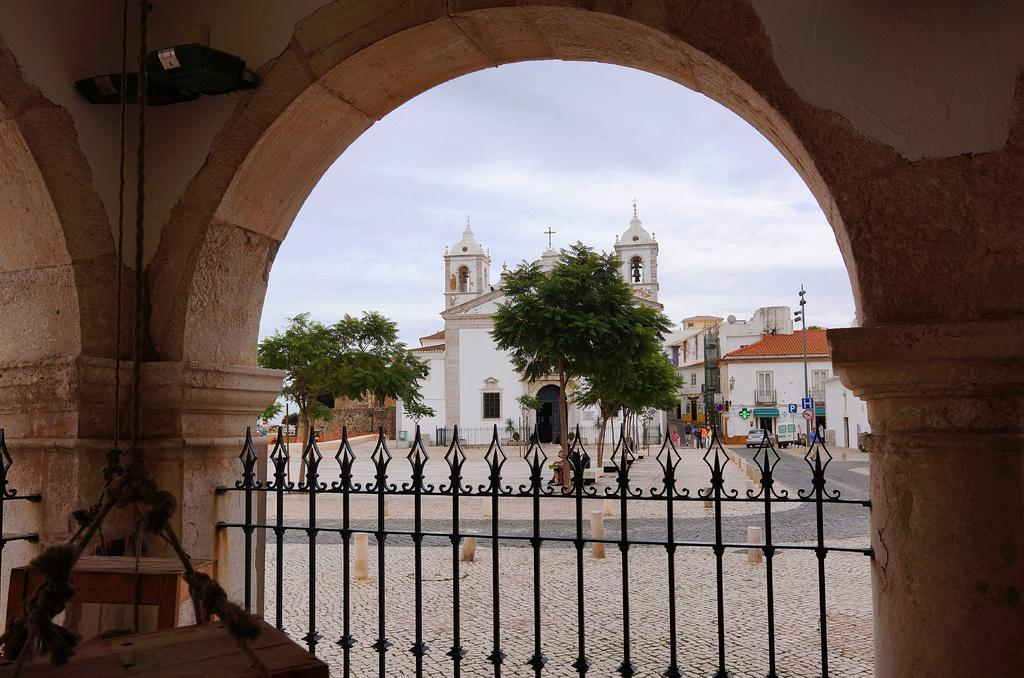What type of structure can be seen in the image? There is an arch in the image. What type of barrier is present in the image? There is a metal fence in the image. What type of buildings are visible in the image? There are buildings with windows in the image. What type of vegetation is present in the image? There are trees in the image. What part of the natural environment is visible in the image? The sky is visible in the image. Where is the queen sitting in the image? There is no queen present in the image. What type of jar is visible in the image? There is no jar present in the image. 